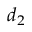Convert formula to latex. <formula><loc_0><loc_0><loc_500><loc_500>d _ { 2 }</formula> 